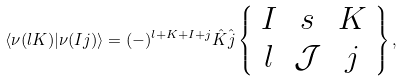Convert formula to latex. <formula><loc_0><loc_0><loc_500><loc_500>\langle \nu ( l K ) | \nu ( I j ) \rangle = ( - ) ^ { l + K + I + j } \hat { K } \hat { j } \left \{ \begin{array} { c c c } I & s & K \\ l & { \mathcal { J } } & j \end{array} \right \} ,</formula> 